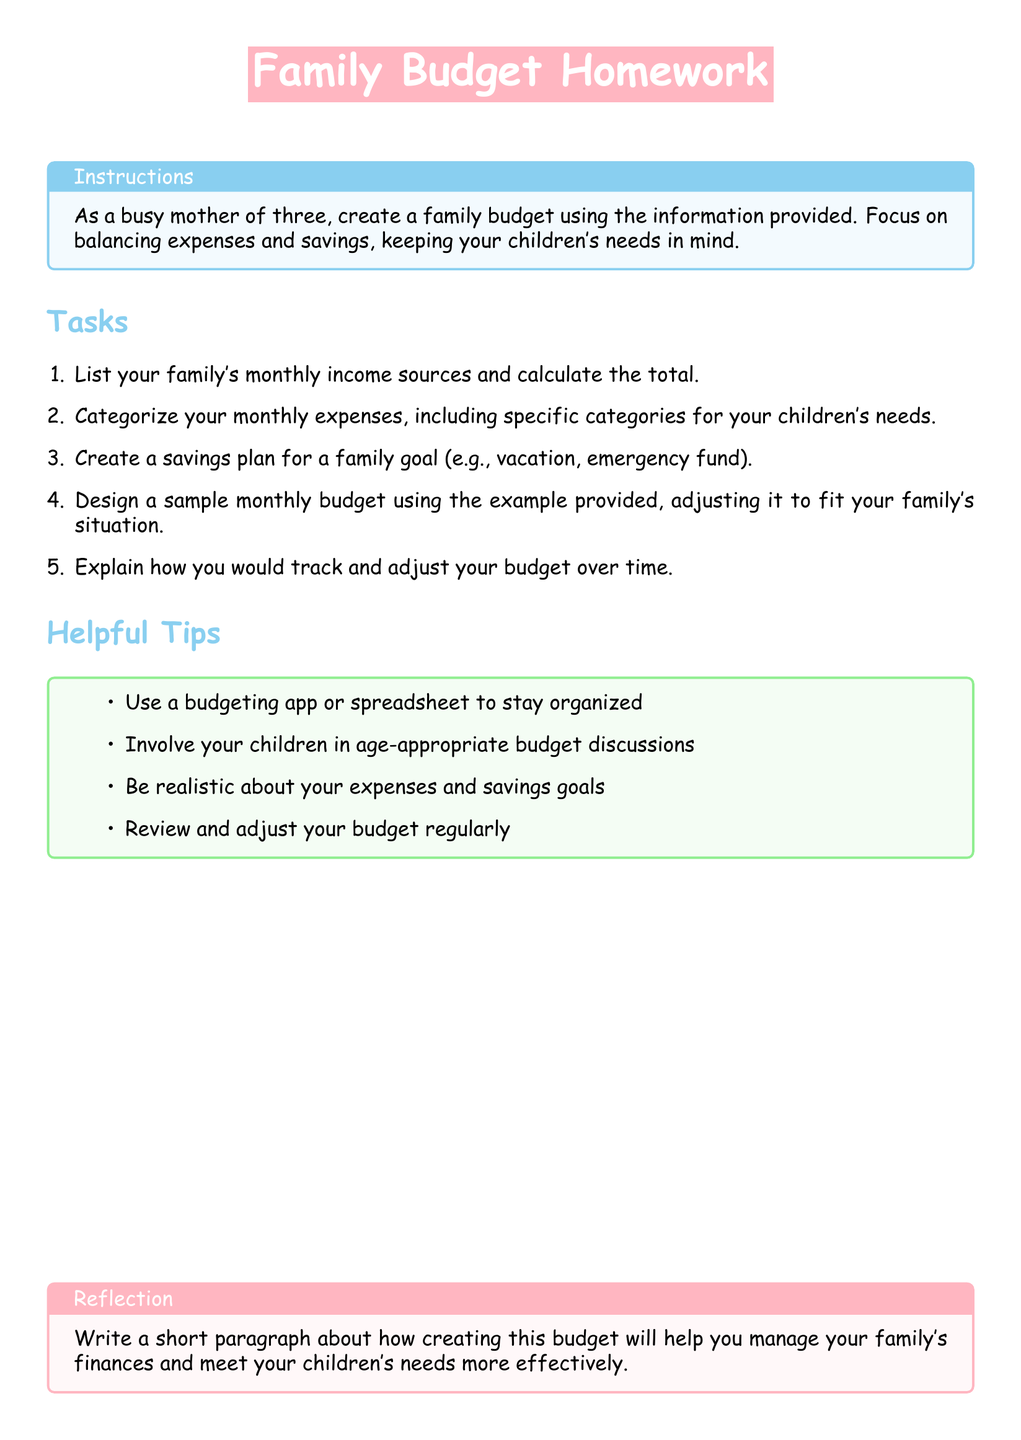what is the focus of the homework? The homework focuses on creating a family budget that balances expenses and savings while considering children's needs.
Answer: balancing expenses and savings with children's needs how many tasks are listed in the document? The document lists a total of five tasks for the family budget homework.
Answer: five what is one of the tips mentioned for organizing the budget? One of the helpful tips suggests using a budgeting app or spreadsheet to stay organized.
Answer: budgeting app or spreadsheet what should be included in the savings plan? The savings plan should include a family goal such as a vacation or an emergency fund.
Answer: vacation or emergency fund what color is used for the title box? The title box uses a pink color labeled as baby pink.
Answer: baby pink how can children be involved in the budgeting process? The document suggests involving children in age-appropriate budget discussions.
Answer: age-appropriate budget discussions what type of document is this? This document is classified as a homework assignment related to family budgeting.
Answer: homework assignment what does the reflection box encourage the reader to write about? The reflection box encourages the reader to write about managing finances and meeting children's needs.
Answer: managing finances and meeting children's needs how should the budget be adjusted over time? The document suggests reviewing and adjusting the budget regularly to ensure effectiveness.
Answer: reviewing and adjusting regularly 